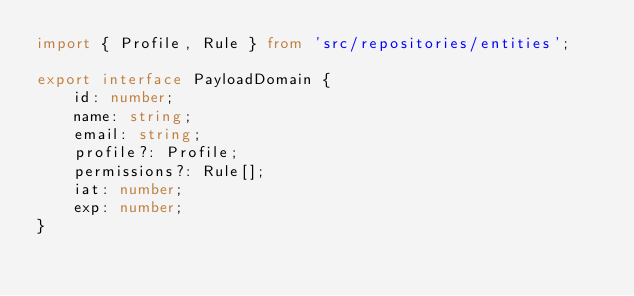Convert code to text. <code><loc_0><loc_0><loc_500><loc_500><_TypeScript_>import { Profile, Rule } from 'src/repositories/entities';

export interface PayloadDomain {
	id: number;
	name: string;
	email: string;
	profile?: Profile;
	permissions?: Rule[];
	iat: number;
	exp: number;
}
</code> 